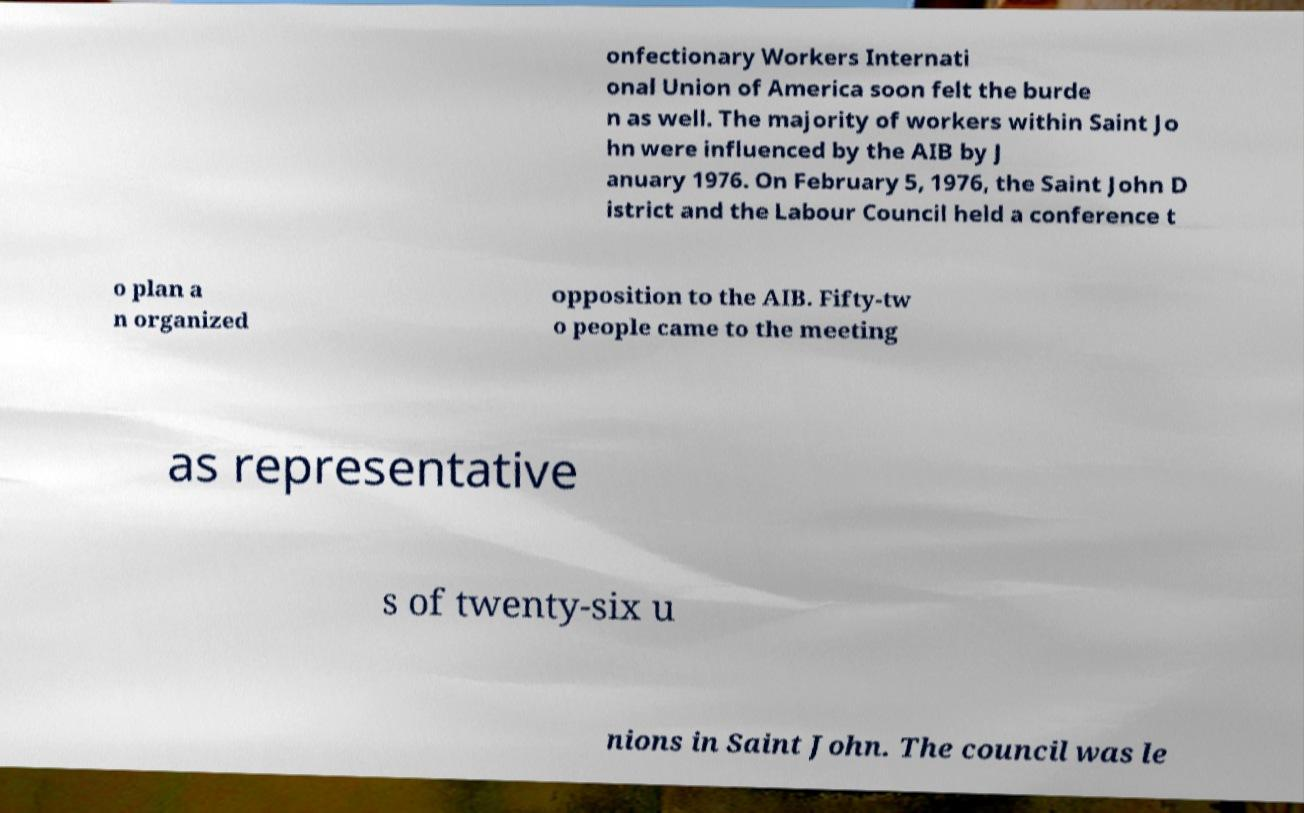Can you read and provide the text displayed in the image?This photo seems to have some interesting text. Can you extract and type it out for me? onfectionary Workers Internati onal Union of America soon felt the burde n as well. The majority of workers within Saint Jo hn were influenced by the AIB by J anuary 1976. On February 5, 1976, the Saint John D istrict and the Labour Council held a conference t o plan a n organized opposition to the AIB. Fifty-tw o people came to the meeting as representative s of twenty-six u nions in Saint John. The council was le 